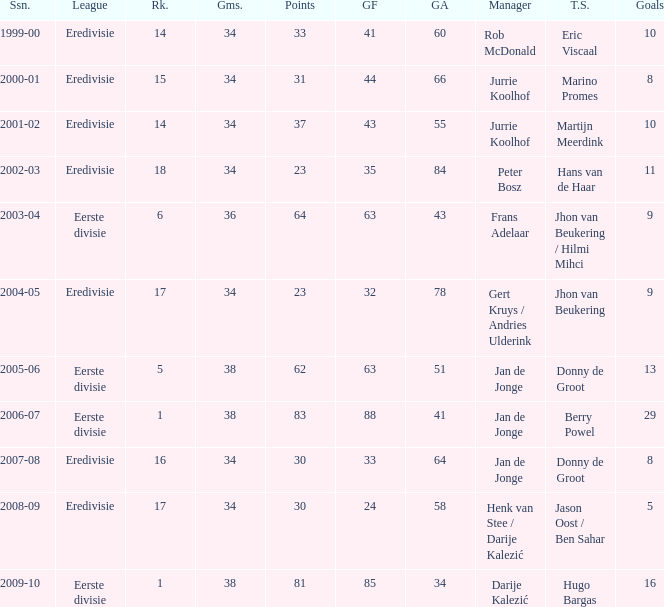Could you parse the entire table? {'header': ['Ssn.', 'League', 'Rk.', 'Gms.', 'Points', 'GF', 'GA', 'Manager', 'T.S.', 'Goals'], 'rows': [['1999-00', 'Eredivisie', '14', '34', '33', '41', '60', 'Rob McDonald', 'Eric Viscaal', '10'], ['2000-01', 'Eredivisie', '15', '34', '31', '44', '66', 'Jurrie Koolhof', 'Marino Promes', '8'], ['2001-02', 'Eredivisie', '14', '34', '37', '43', '55', 'Jurrie Koolhof', 'Martijn Meerdink', '10'], ['2002-03', 'Eredivisie', '18', '34', '23', '35', '84', 'Peter Bosz', 'Hans van de Haar', '11'], ['2003-04', 'Eerste divisie', '6', '36', '64', '63', '43', 'Frans Adelaar', 'Jhon van Beukering / Hilmi Mihci', '9'], ['2004-05', 'Eredivisie', '17', '34', '23', '32', '78', 'Gert Kruys / Andries Ulderink', 'Jhon van Beukering', '9'], ['2005-06', 'Eerste divisie', '5', '38', '62', '63', '51', 'Jan de Jonge', 'Donny de Groot', '13'], ['2006-07', 'Eerste divisie', '1', '38', '83', '88', '41', 'Jan de Jonge', 'Berry Powel', '29'], ['2007-08', 'Eredivisie', '16', '34', '30', '33', '64', 'Jan de Jonge', 'Donny de Groot', '8'], ['2008-09', 'Eredivisie', '17', '34', '30', '24', '58', 'Henk van Stee / Darije Kalezić', 'Jason Oost / Ben Sahar', '5'], ['2009-10', 'Eerste divisie', '1', '38', '81', '85', '34', 'Darije Kalezić', 'Hugo Bargas', '16']]} Who is the top scorer where gf is 41? Eric Viscaal. 